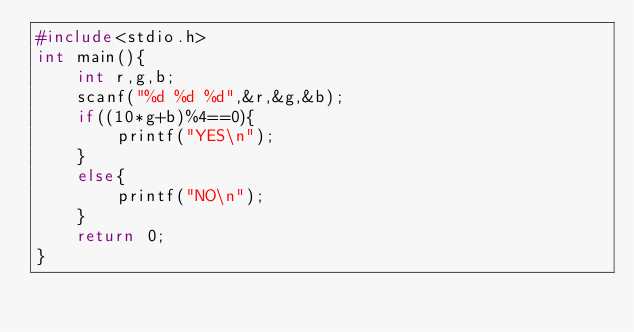<code> <loc_0><loc_0><loc_500><loc_500><_C_>#include<stdio.h>
int main(){
    int r,g,b;
    scanf("%d %d %d",&r,&g,&b);
    if((10*g+b)%4==0){
        printf("YES\n");
    }
    else{
        printf("NO\n");
    }
    return 0;
}</code> 